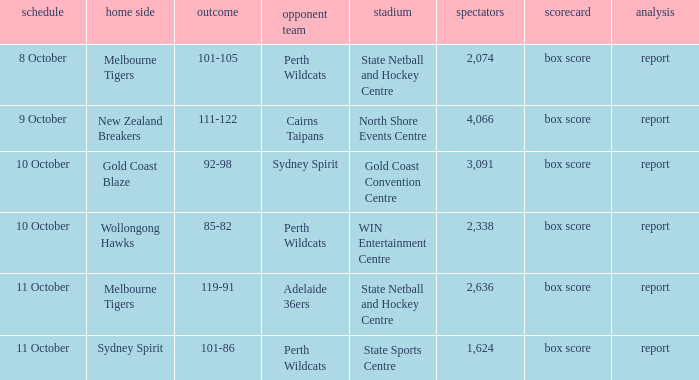What was the average crowd size for the game when the Gold Coast Blaze was the home team? 3091.0. 